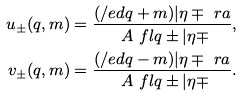<formula> <loc_0><loc_0><loc_500><loc_500>u _ { \pm } ( q , m ) & = \frac { ( \slash e d { q } + m ) | \eta \mp \ r a } { \ A { \ f l q \pm | } { \eta \mp } } , \\ v _ { \pm } ( q , m ) & = \frac { ( \slash e d { q } - m ) | \eta \mp \ r a } { \ A { \ f l q \pm | } { \eta \mp } } .</formula> 